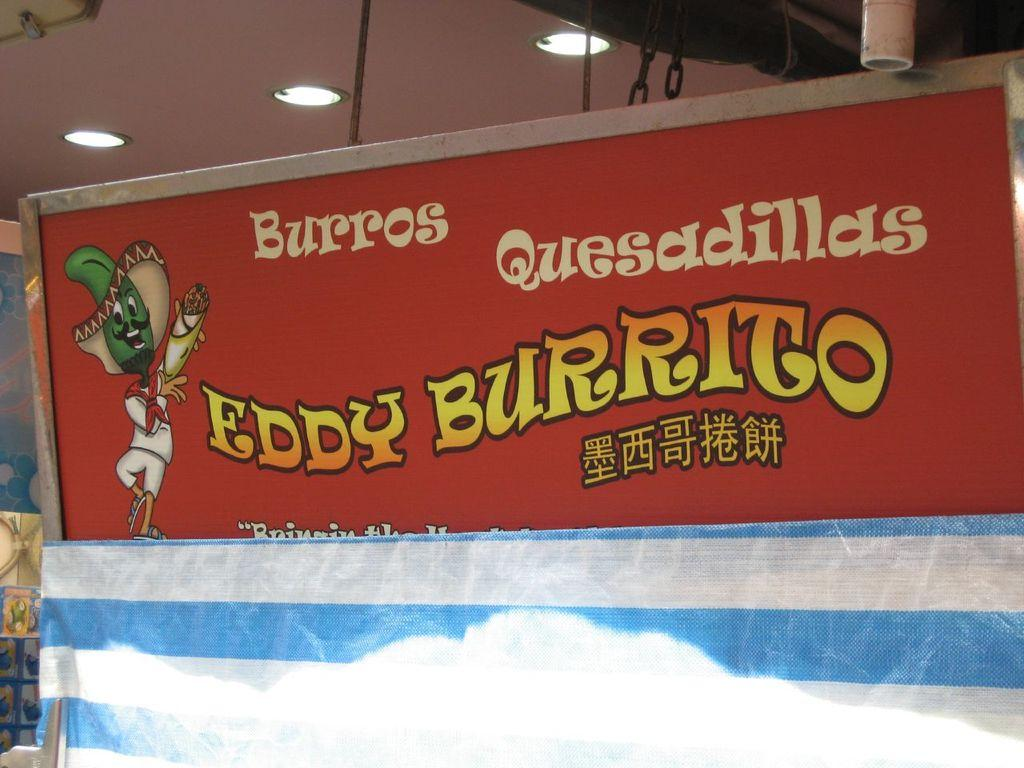<image>
Create a compact narrative representing the image presented. A red sign for Eddy Burrito burros and quesadillas has a cartoon pepper in a sombrero. 